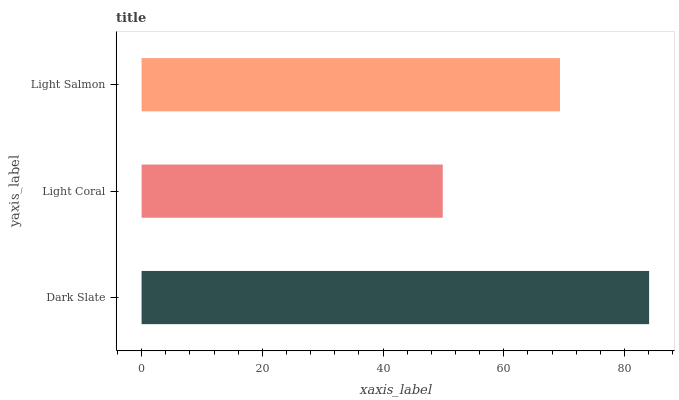Is Light Coral the minimum?
Answer yes or no. Yes. Is Dark Slate the maximum?
Answer yes or no. Yes. Is Light Salmon the minimum?
Answer yes or no. No. Is Light Salmon the maximum?
Answer yes or no. No. Is Light Salmon greater than Light Coral?
Answer yes or no. Yes. Is Light Coral less than Light Salmon?
Answer yes or no. Yes. Is Light Coral greater than Light Salmon?
Answer yes or no. No. Is Light Salmon less than Light Coral?
Answer yes or no. No. Is Light Salmon the high median?
Answer yes or no. Yes. Is Light Salmon the low median?
Answer yes or no. Yes. Is Dark Slate the high median?
Answer yes or no. No. Is Light Coral the low median?
Answer yes or no. No. 